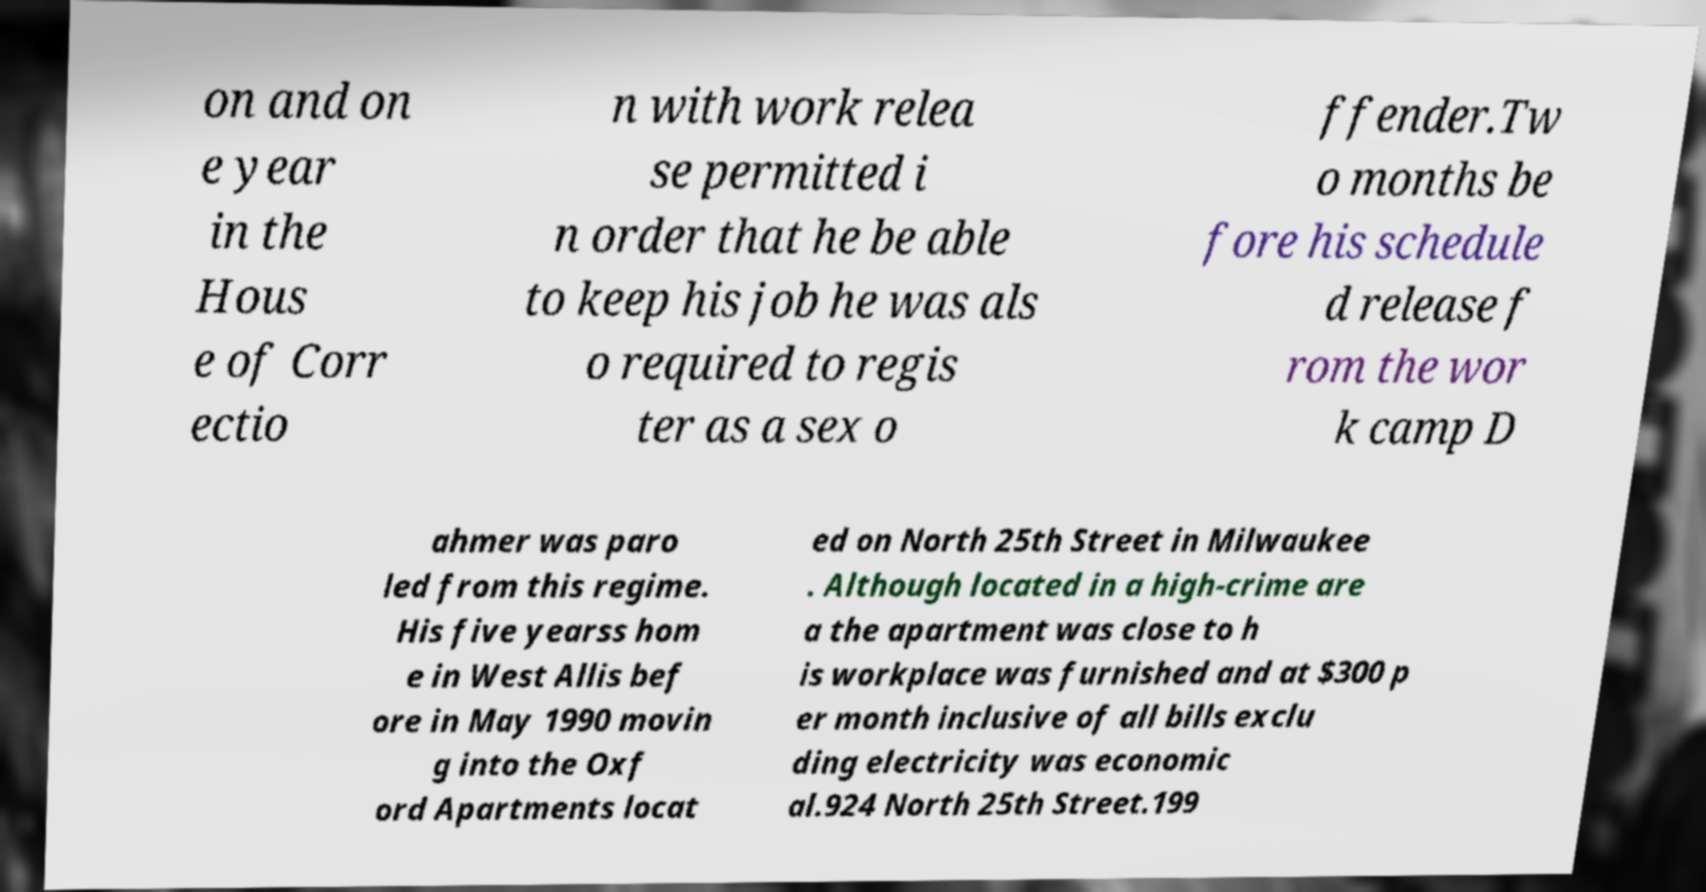Please identify and transcribe the text found in this image. on and on e year in the Hous e of Corr ectio n with work relea se permitted i n order that he be able to keep his job he was als o required to regis ter as a sex o ffender.Tw o months be fore his schedule d release f rom the wor k camp D ahmer was paro led from this regime. His five yearss hom e in West Allis bef ore in May 1990 movin g into the Oxf ord Apartments locat ed on North 25th Street in Milwaukee . Although located in a high-crime are a the apartment was close to h is workplace was furnished and at $300 p er month inclusive of all bills exclu ding electricity was economic al.924 North 25th Street.199 